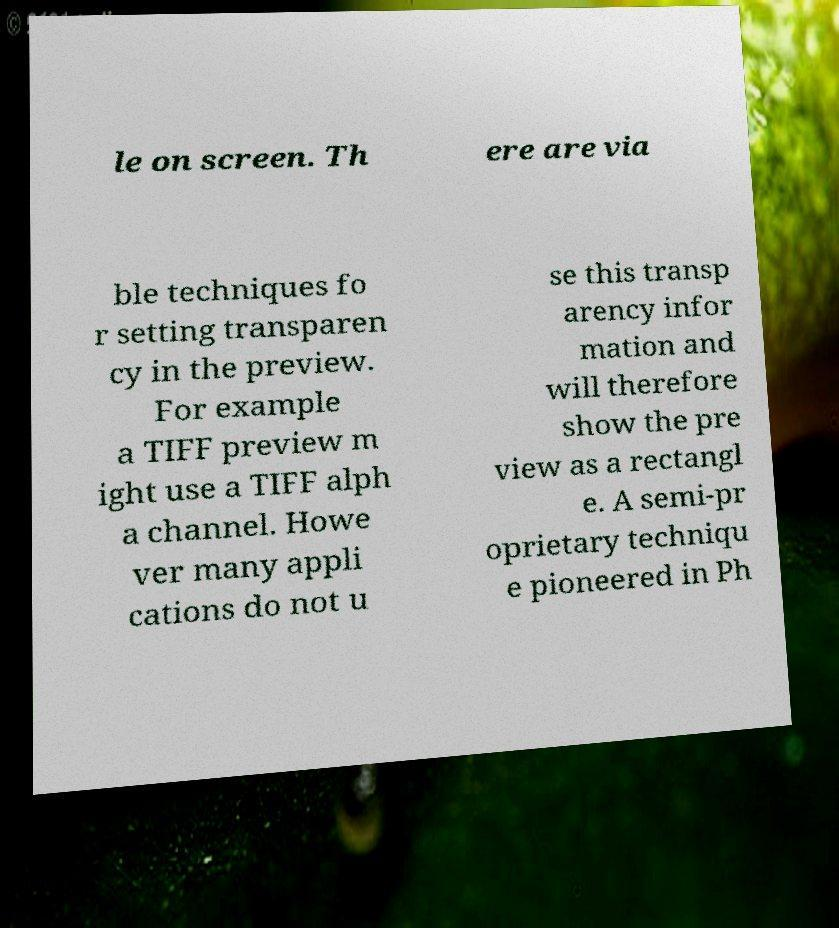There's text embedded in this image that I need extracted. Can you transcribe it verbatim? le on screen. Th ere are via ble techniques fo r setting transparen cy in the preview. For example a TIFF preview m ight use a TIFF alph a channel. Howe ver many appli cations do not u se this transp arency infor mation and will therefore show the pre view as a rectangl e. A semi-pr oprietary techniqu e pioneered in Ph 